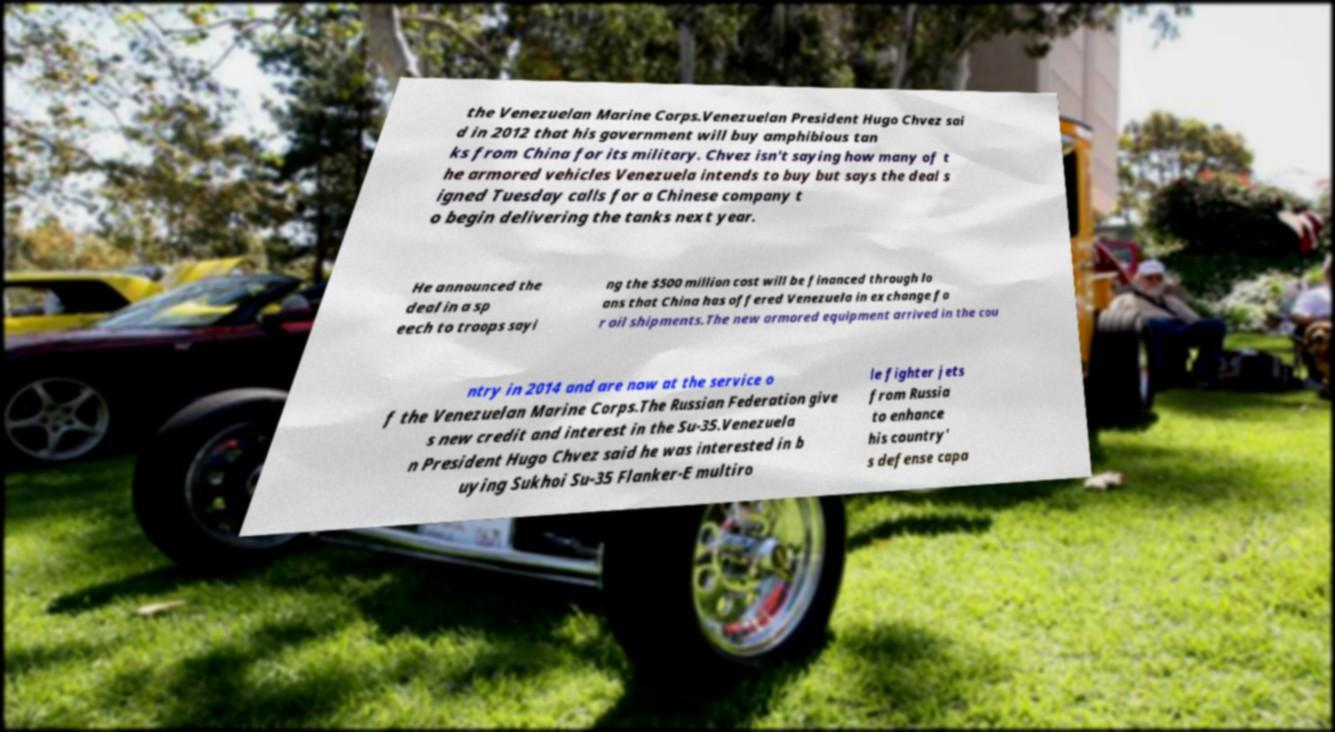There's text embedded in this image that I need extracted. Can you transcribe it verbatim? the Venezuelan Marine Corps.Venezuelan President Hugo Chvez sai d in 2012 that his government will buy amphibious tan ks from China for its military. Chvez isn't saying how many of t he armored vehicles Venezuela intends to buy but says the deal s igned Tuesday calls for a Chinese company t o begin delivering the tanks next year. He announced the deal in a sp eech to troops sayi ng the $500 million cost will be financed through lo ans that China has offered Venezuela in exchange fo r oil shipments.The new armored equipment arrived in the cou ntry in 2014 and are now at the service o f the Venezuelan Marine Corps.The Russian Federation give s new credit and interest in the Su-35.Venezuela n President Hugo Chvez said he was interested in b uying Sukhoi Su-35 Flanker-E multiro le fighter jets from Russia to enhance his country' s defense capa 